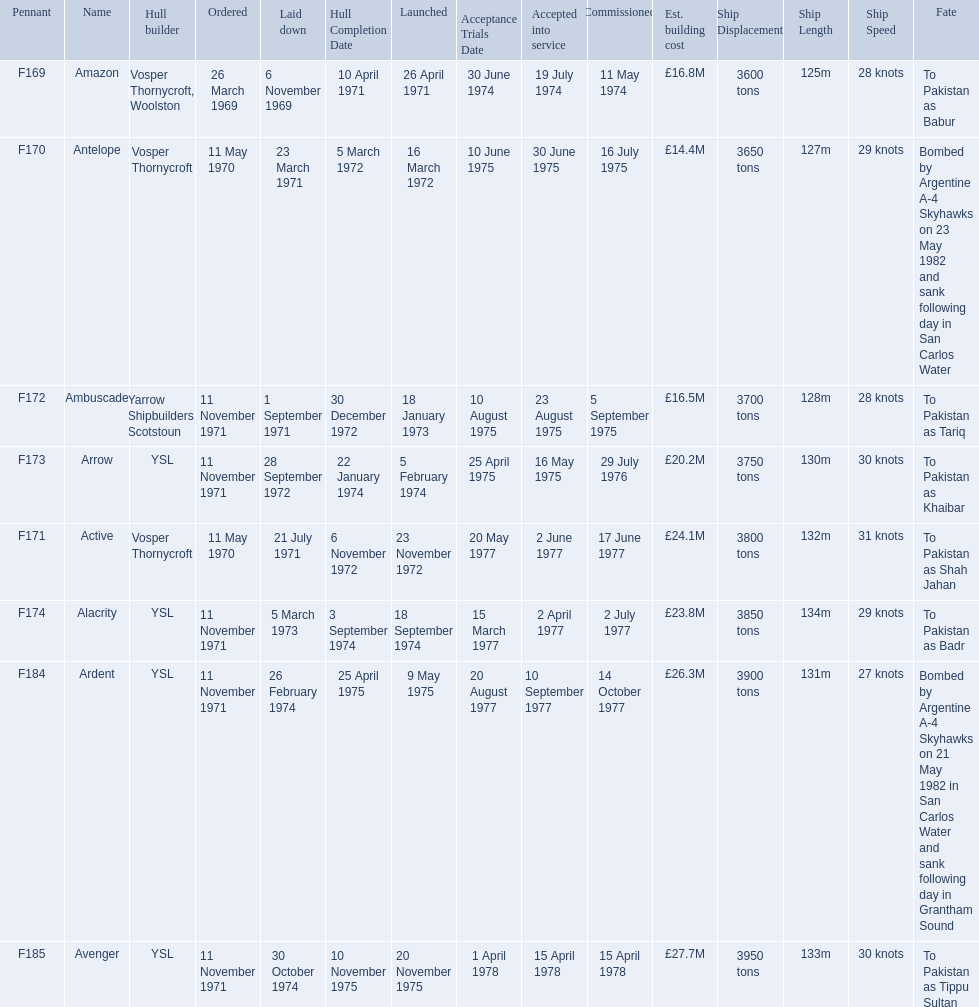Which type 21 frigate ships were to be built by ysl in the 1970s? Arrow, Alacrity, Ardent, Avenger. Of these ships, which one had the highest estimated building cost? Avenger. What were the estimated building costs of the frigates? £16.8M, £14.4M, £16.5M, £20.2M, £24.1M, £23.8M, £26.3M, £27.7M. Which of these is the largest? £27.7M. What ship name does that correspond to? Avenger. 